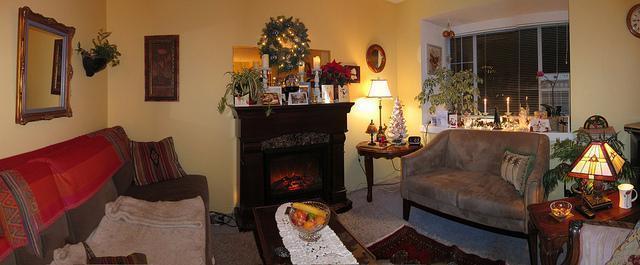What is the white object on the coffee table called?
From the following set of four choices, select the accurate answer to respond to the question.
Options: Doily, towel, cover, tablecloth. Doily. 